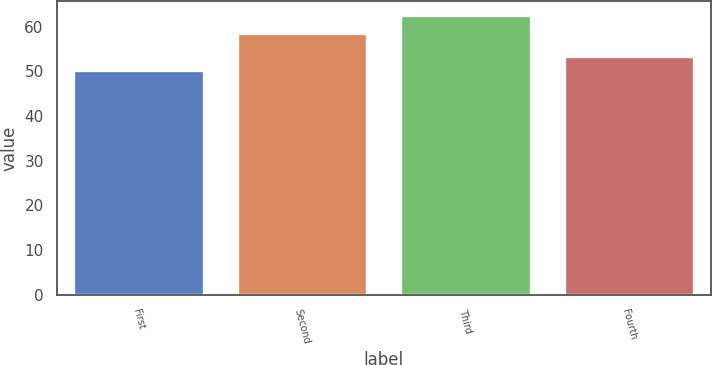Convert chart to OTSL. <chart><loc_0><loc_0><loc_500><loc_500><bar_chart><fcel>First<fcel>Second<fcel>Third<fcel>Fourth<nl><fcel>50.35<fcel>58.52<fcel>62.61<fcel>53.49<nl></chart> 